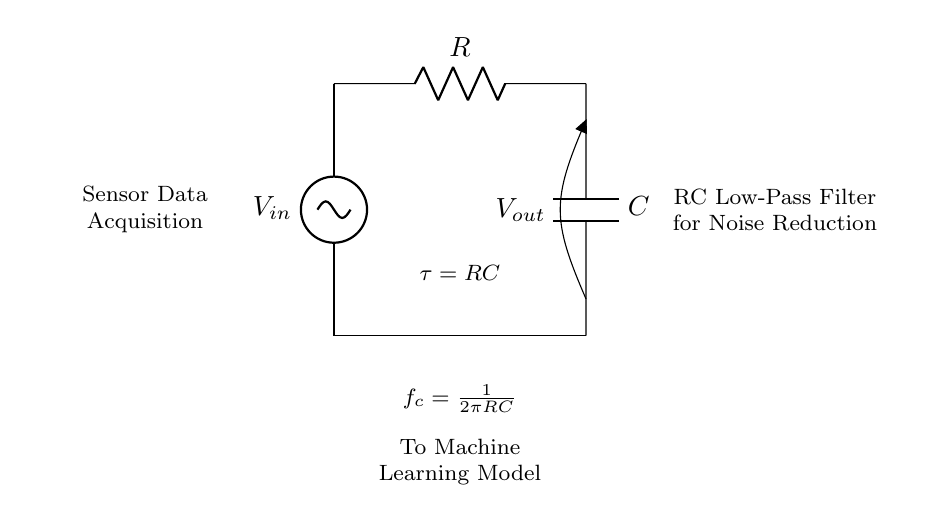What is the input voltage in the circuit? The input voltage \( V_{in} \) represents the voltage source connected at the top of the RC circuit. The circuit shows this as a voltage source but does not specifically label a numerical value.
Answer: \( V_{in} \) What components are used in this RC circuit? The diagram illustrates a resistor labeled \( R \) and a capacitor labeled \( C \) connected between the input voltage source and ground.
Answer: Resistor and Capacitor What does the time constant \( \tau \) represent in this circuit? The time constant \( \tau = RC \) indicates how quickly the capacitor charges and discharges. It is a critical parameter in determining the circuit's response time to changes in input voltage.
Answer: RC What is the cutoff frequency \( f_c \)? The cutoff frequency \( f_c = \frac{1}{2\pi RC} \) defines the frequency at which the output voltage is reduced to \( 70.7\% \) of the input voltage in a low-pass RC filter. This helps in understanding how effectively the circuit can filter out noise from sensor signals.
Answer: \( \frac{1}{2\pi RC} \) What is the purpose of this RC circuit in relation to sensor data acquisition? The circuit is marked with annotations indicating it functions as a low-pass filter, aiding in noise reduction for sensor data acquisition before passing the information to a machine learning model.
Answer: Noise reduction 